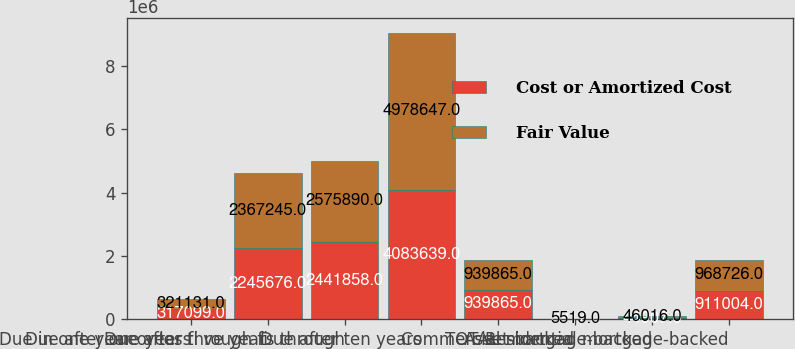Convert chart. <chart><loc_0><loc_0><loc_500><loc_500><stacked_bar_chart><ecel><fcel>Due in one year or less<fcel>Due after one year through fi<fcel>Due after fi ve years through<fcel>Due after ten years<fcel>TOTAL<fcel>Asset-backed<fcel>Commercial mortgage-backed<fcel>Residential mortgage-backed<nl><fcel>Cost or Amortized Cost<fcel>317099<fcel>2.24568e+06<fcel>2.44186e+06<fcel>4.08364e+06<fcel>939865<fcel>3917<fcel>44907<fcel>911004<nl><fcel>Fair Value<fcel>321131<fcel>2.36724e+06<fcel>2.57589e+06<fcel>4.97865e+06<fcel>939865<fcel>5519<fcel>46016<fcel>968726<nl></chart> 